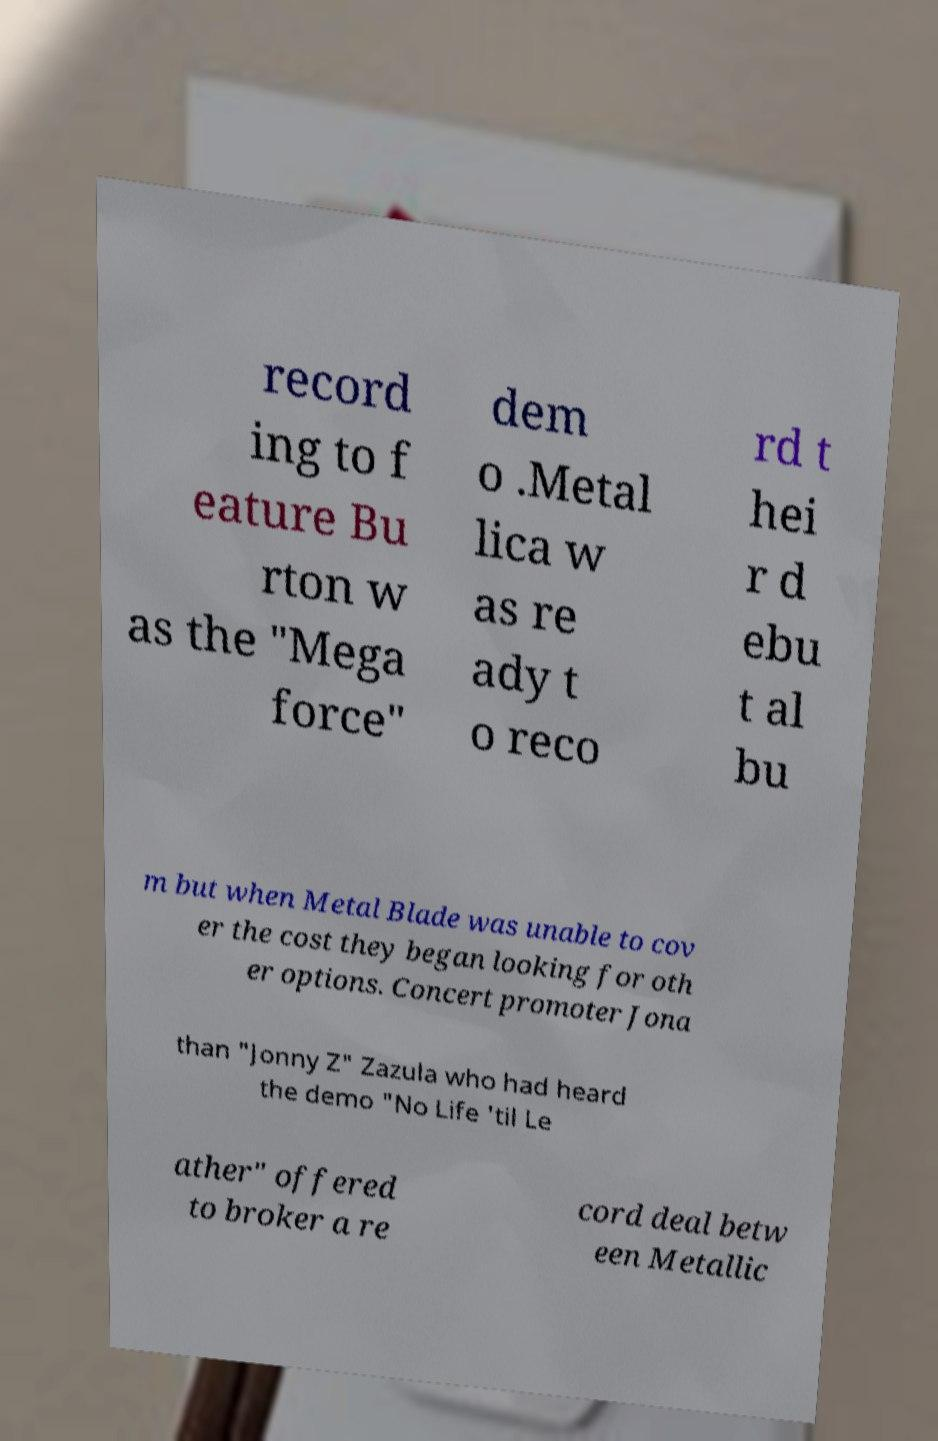Please identify and transcribe the text found in this image. record ing to f eature Bu rton w as the "Mega force" dem o .Metal lica w as re ady t o reco rd t hei r d ebu t al bu m but when Metal Blade was unable to cov er the cost they began looking for oth er options. Concert promoter Jona than "Jonny Z" Zazula who had heard the demo "No Life 'til Le ather" offered to broker a re cord deal betw een Metallic 